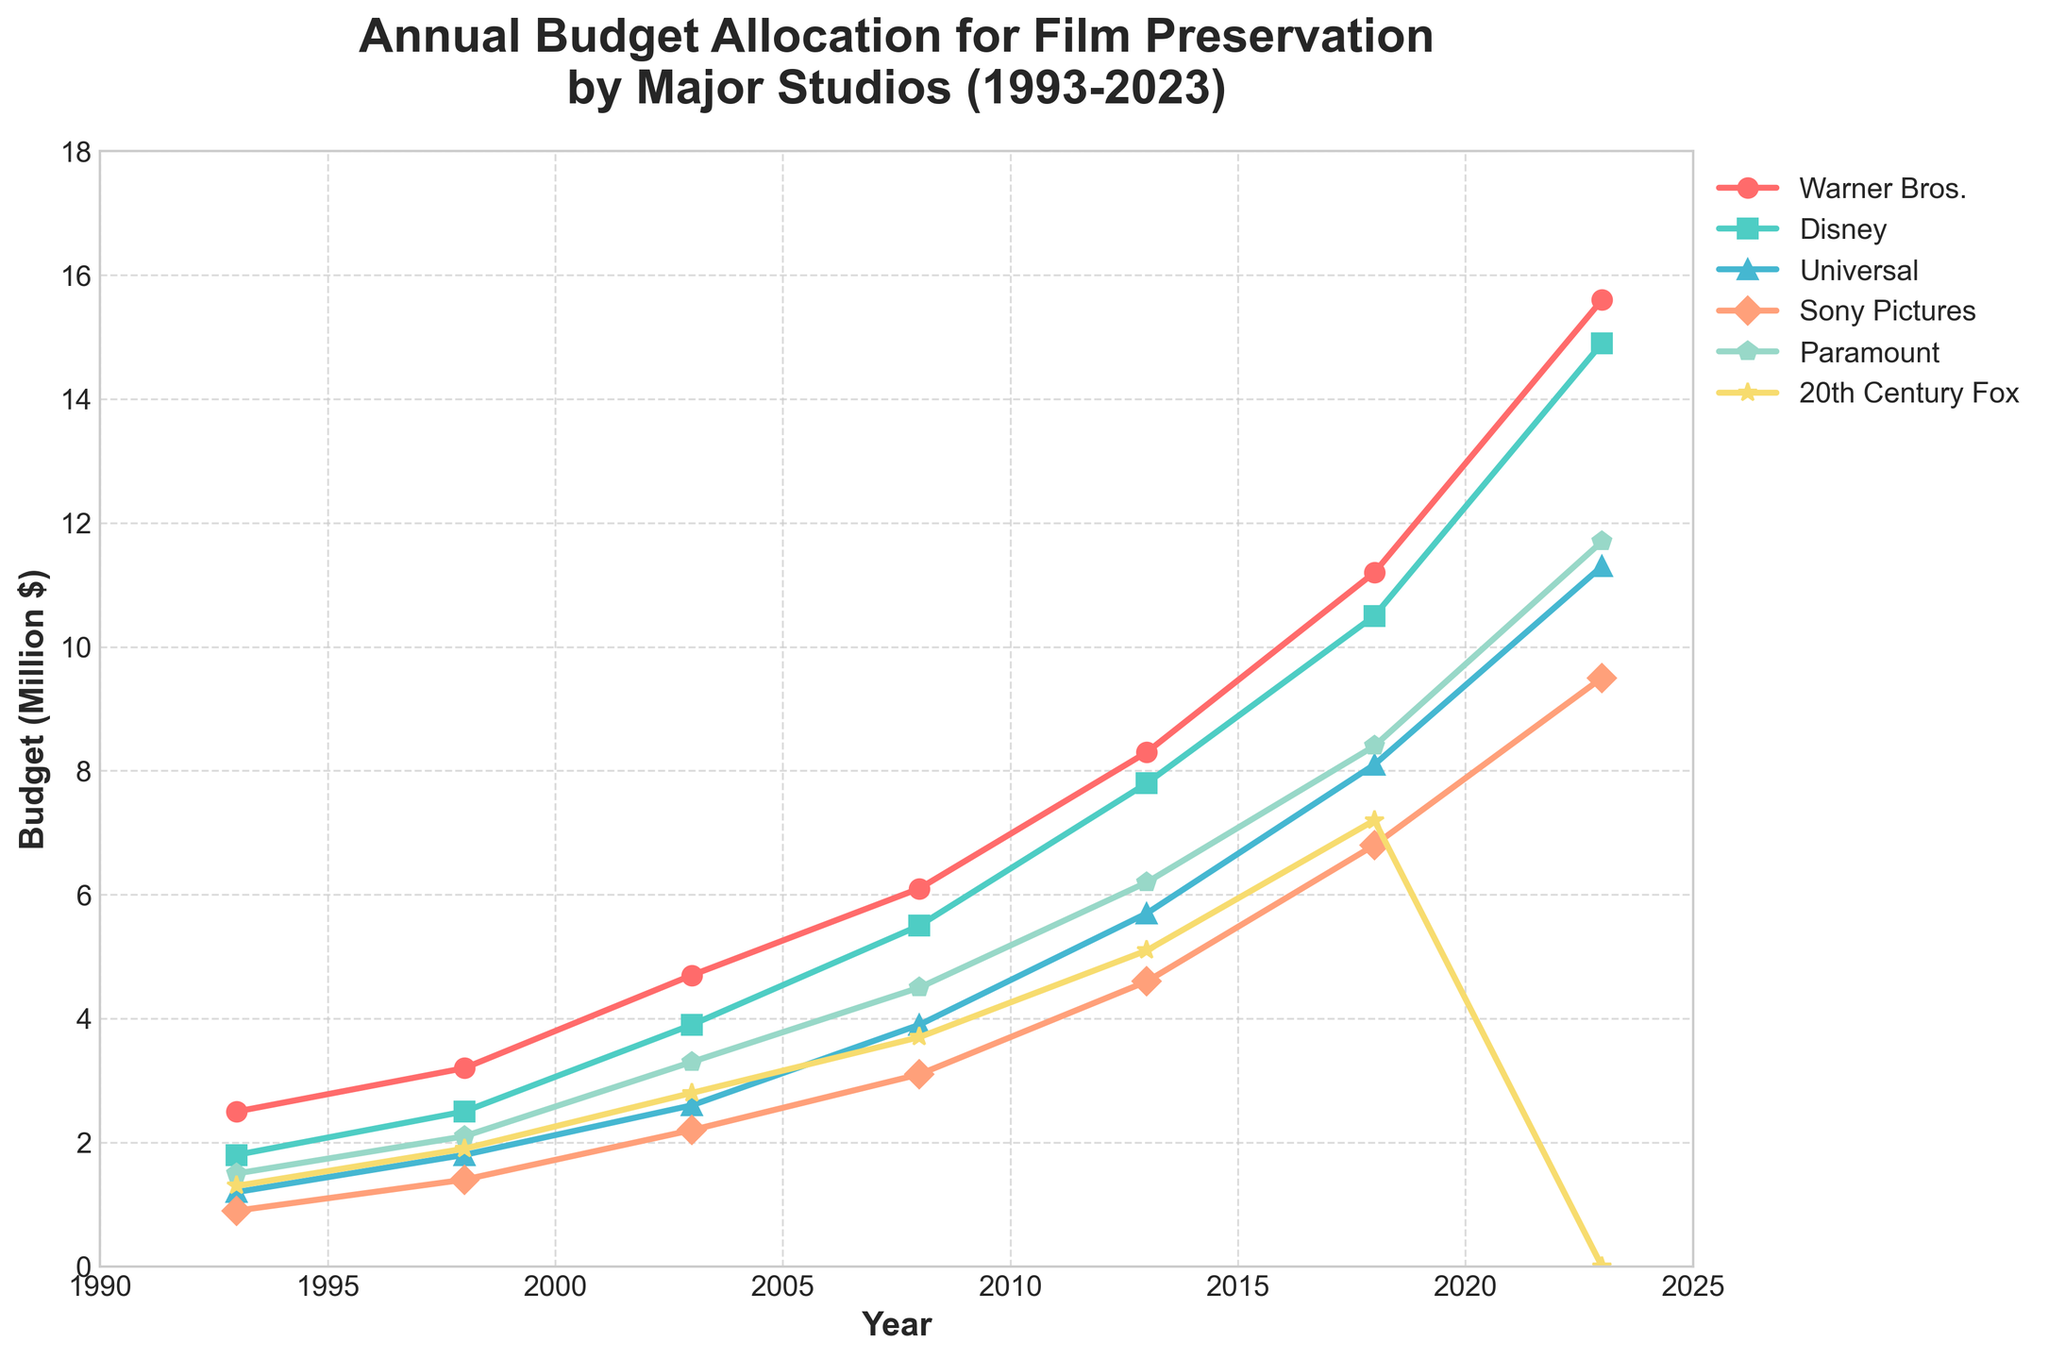Which studio had the highest budget allocation for film preservation in 2023? The highest budget allocation for 2023 can be found by identifying the studio with the highest data point on the rightmost side of the line chart. Warner Bros. has the highest point at 15.6 million dollars.
Answer: Warner Bros What was the average annual budget for Disney in 2008 and 2013? To find the average, first sum the budgets for Disney in 2008 and 2013 (5.5 + 7.8 = 13.3), then divide by 2, which results in an average of 6.65 million dollars.
Answer: 6.65 How did the budget for 20th Century Fox change from 2018 to 2023? The budget for 20th Century Fox in 2018 was 7.2 million dollars and dropped to 0 million dollars in 2023. The change is 7.2 - 0 = 7.2 million dollars decrease.
Answer: 7.2 million dollars decrease Which studio had the least budget allocation in 1993? The least budget allocation in 1993 can be found by identifying the lowest data point on the leftmost side of the line chart. Sony Pictures has the lowest at 0.9 million dollars.
Answer: Sony Pictures Compare the budget allocations of Universal and Paramount in 2013. Which is higher, and by how much? In 2013, Universal allocated 5.7 million dollars and Paramount allocated 6.2 million dollars. Paramount’s budget is higher by 6.2 - 5.7 = 0.5 million dollars.
Answer: Paramount, by 0.5 million dollars Which year showed the most significant increase in Warner Bros.’s budget compared to the previous data point? To find the most significant increase, subtract each year’s budget from the next for Warner Bros. The most significant increase is from 2018 (11.2) to 2023 (15.6), which is 15.6 - 11.2 = 4.4 million dollars.
Answer: 2018 to 2023 Considering all studios, what was the total budget allocated for film preservation in 2003? Sum the budget allocations for all studios in 2003: 4.7 + 3.9 + 2.6 + 2.2 + 3.3 + 2.8, which results in 19.5 million dollars.
Answer: 19.5 million dollars Between which consecutive years did Disney see the largest budget increase? To find the largest increase, subtract each year’s budget from the next for Disney. The largest increase is from 2013 (7.8) to 2018 (10.5), which is 10.5 - 7.8 = 2.7 million dollars.
Answer: 2013 to 2018 What is the median budget allocation for Paramount over the given period? List Paramount's budgets from smallest to largest: 1.5, 2.1, 3.3, 4.5, 6.2, 8.4, 11.7. With 7 values, the median is the 4th value, which is 4.5 million dollars.
Answer: 4.5 million dollars 